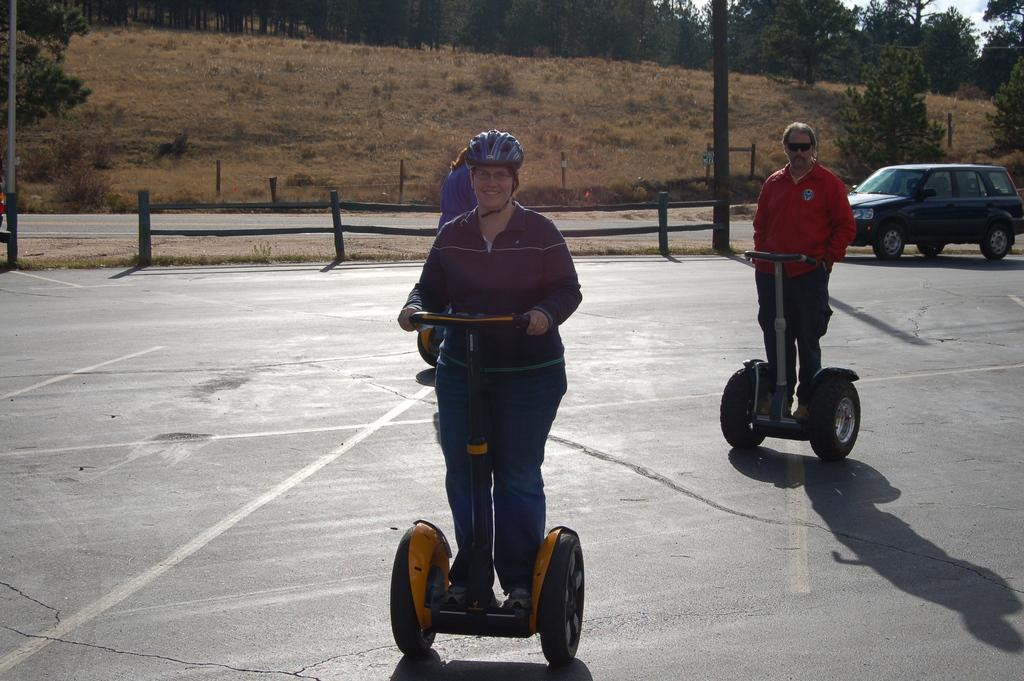What are the persons in the image doing? The persons in the image are riding vehicles. Can you describe the clothing of one of the persons? One person is wearing a red shirt and black pants. What can be seen in the background of the image? There is a vehicle and trees with green leaves in the background. How would you describe the color of the sky in the image? The sky appears to be white in color. What type of marble is being used to decorate the vehicles in the image? There is no marble present in the image; the vehicles are not being decorated with marble. How many clocks can be seen in the image? There are no clocks visible in the image. 